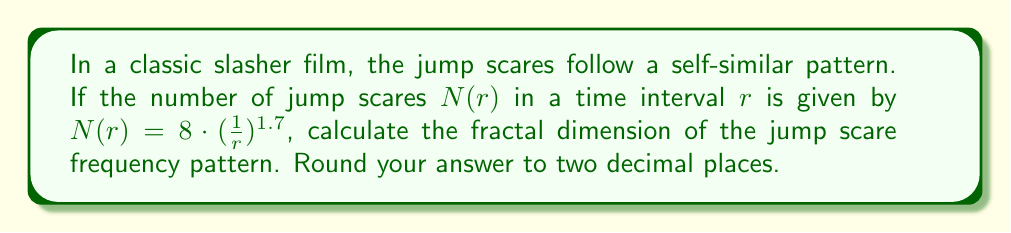Solve this math problem. To calculate the fractal dimension of the jump scare frequency pattern, we'll use the box-counting method. The fractal dimension $D$ is given by the formula:

$$ D = \lim_{r \to 0} \frac{\log N(r)}{\log(\frac{1}{r})} $$

Where $N(r)$ is the number of boxes (in this case, jump scares) of size $r$ needed to cover the set.

Given: $N(r) = 8 \cdot (\frac{1}{r})^{1.7}$

Step 1: Take the logarithm of both sides:
$$ \log N(r) = \log(8 \cdot (\frac{1}{r})^{1.7}) $$

Step 2: Use the properties of logarithms:
$$ \log N(r) = \log 8 + 1.7 \log(\frac{1}{r}) $$

Step 3: Divide both sides by $\log(\frac{1}{r})$:
$$ \frac{\log N(r)}{\log(\frac{1}{r})} = \frac{\log 8}{\log(\frac{1}{r})} + 1.7 $$

Step 4: Take the limit as $r$ approaches 0:
$$ \lim_{r \to 0} \frac{\log N(r)}{\log(\frac{1}{r})} = \lim_{r \to 0} (\frac{\log 8}{\log(\frac{1}{r})} + 1.7) $$

Step 5: As $r$ approaches 0, $\log(\frac{1}{r})$ approaches infinity, so $\frac{\log 8}{\log(\frac{1}{r})}$ approaches 0:
$$ D = \lim_{r \to 0} \frac{\log N(r)}{\log(\frac{1}{r})} = 0 + 1.7 = 1.7 $$

Step 6: Round to two decimal places:
$$ D \approx 1.70 $$
Answer: 1.70 